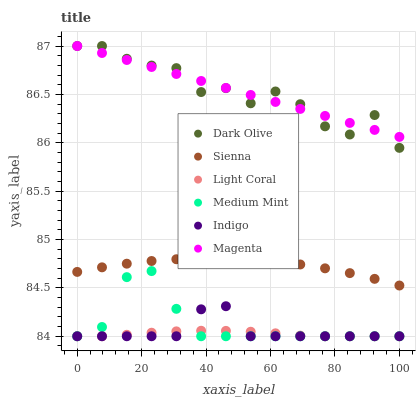Does Light Coral have the minimum area under the curve?
Answer yes or no. Yes. Does Magenta have the maximum area under the curve?
Answer yes or no. Yes. Does Indigo have the minimum area under the curve?
Answer yes or no. No. Does Indigo have the maximum area under the curve?
Answer yes or no. No. Is Magenta the smoothest?
Answer yes or no. Yes. Is Dark Olive the roughest?
Answer yes or no. Yes. Is Light Coral the smoothest?
Answer yes or no. No. Is Light Coral the roughest?
Answer yes or no. No. Does Medium Mint have the lowest value?
Answer yes or no. Yes. Does Dark Olive have the lowest value?
Answer yes or no. No. Does Magenta have the highest value?
Answer yes or no. Yes. Does Indigo have the highest value?
Answer yes or no. No. Is Indigo less than Sienna?
Answer yes or no. Yes. Is Dark Olive greater than Light Coral?
Answer yes or no. Yes. Does Indigo intersect Light Coral?
Answer yes or no. Yes. Is Indigo less than Light Coral?
Answer yes or no. No. Is Indigo greater than Light Coral?
Answer yes or no. No. Does Indigo intersect Sienna?
Answer yes or no. No. 